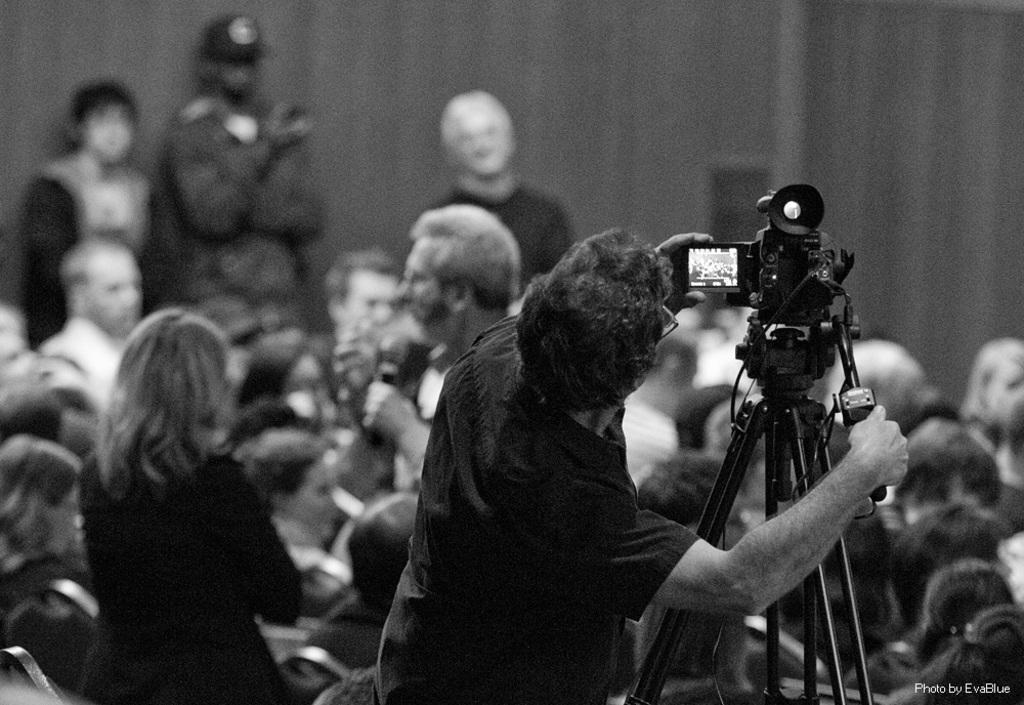Please provide a concise description of this image. In this image we can see people standing and some of them are sitting. On the right there is a camera placed on the stand. In the background there is a wall. 